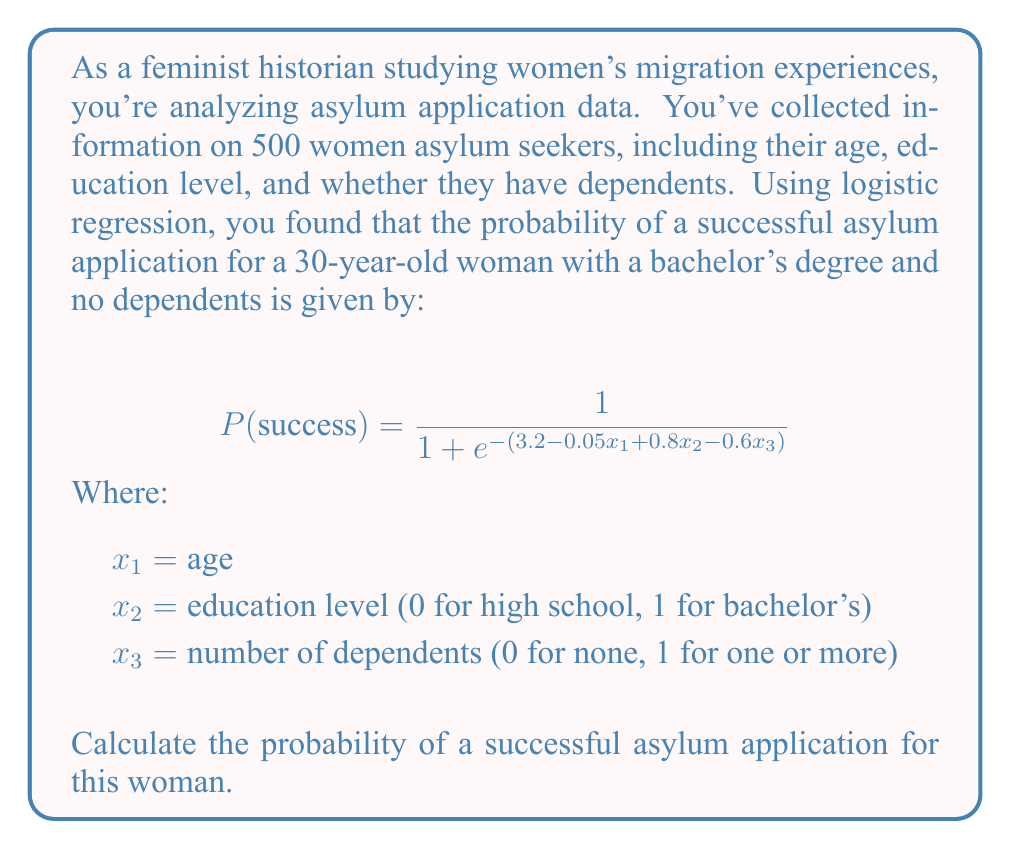Provide a solution to this math problem. To solve this problem, we need to follow these steps:

1. Identify the values for each variable:
   $x_1 = 30$ (age)
   $x_2 = 1$ (bachelor's degree)
   $x_3 = 0$ (no dependents)

2. Substitute these values into the equation inside the exponential:
   $3.2 - 0.05x_1 + 0.8x_2 - 0.6x_3$
   $= 3.2 - 0.05(30) + 0.8(1) - 0.6(0)$
   $= 3.2 - 1.5 + 0.8 - 0$
   $= 2.5$

3. Calculate $e^{-2.5}$:
   $e^{-2.5} \approx 0.0821$

4. Substitute this value into the main equation:
   $$P(success) = \frac{1}{1 + e^{-2.5}} = \frac{1}{1 + 0.0821} = \frac{1}{1.0821}$$

5. Calculate the final probability:
   $$P(success) = \frac{1}{1.0821} \approx 0.9241$$

6. Convert to a percentage:
   $0.9241 \times 100\% = 92.41\%$
Answer: 92.41% 